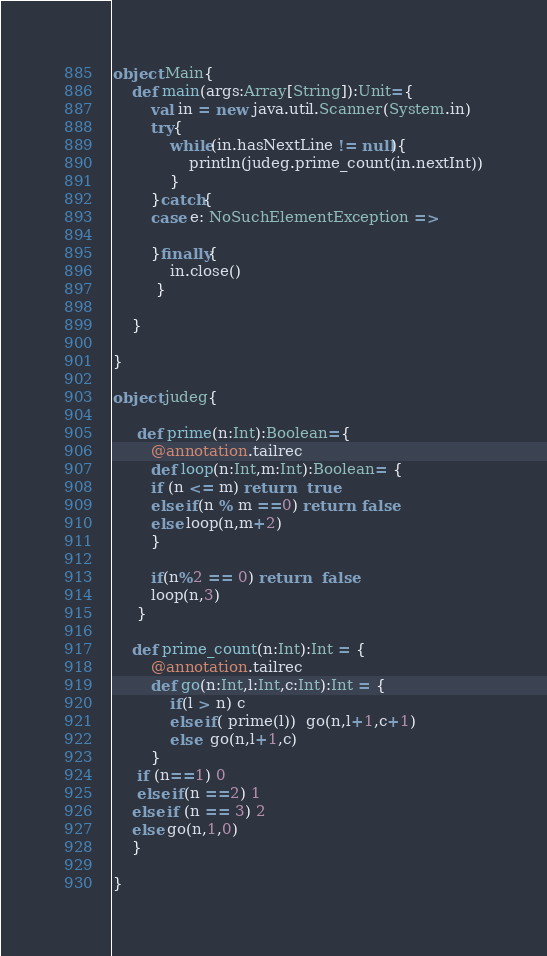Convert code to text. <code><loc_0><loc_0><loc_500><loc_500><_Scala_>object Main{
    def main(args:Array[String]):Unit={
        val in = new java.util.Scanner(System.in)
        try{
            while(in.hasNextLine != null){
                println(judeg.prime_count(in.nextInt))
            }
        }catch{
        case e: NoSuchElementException =>

        }finally{
            in.close()
         }

    }

}

object judeg{

     def prime(n:Int):Boolean={
        @annotation.tailrec
        def loop(n:Int,m:Int):Boolean= {
        if (n <= m) return   true
        else if(n % m ==0) return  false
        else loop(n,m+2)
        }

        if(n%2 == 0) return   false
        loop(n,3)
     }

    def prime_count(n:Int):Int = {
        @annotation.tailrec
        def go(n:Int,l:Int,c:Int):Int = {
            if(l > n) c
            else if( prime(l))  go(n,l+1,c+1)
            else  go(n,l+1,c)
        }
     if (n==1) 0
     else if(n ==2) 1
    else if (n == 3) 2
    else go(n,1,0)
    }

}</code> 